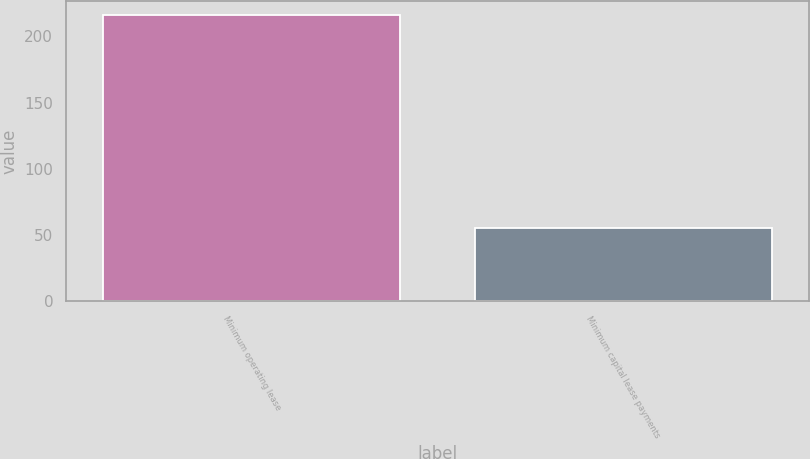Convert chart to OTSL. <chart><loc_0><loc_0><loc_500><loc_500><bar_chart><fcel>Minimum operating lease<fcel>Minimum capital lease payments<nl><fcel>216<fcel>55<nl></chart> 